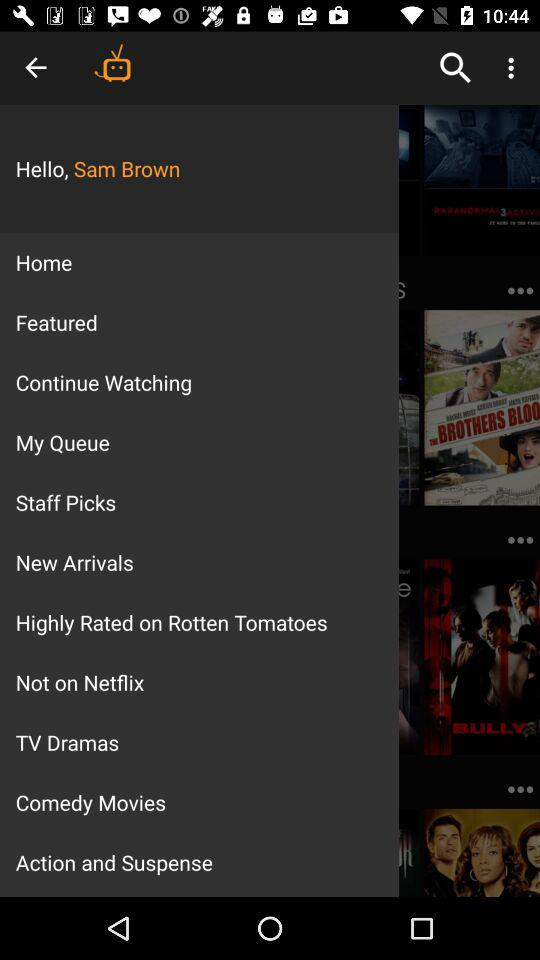What is the user name? The user name is Sam Brown. 